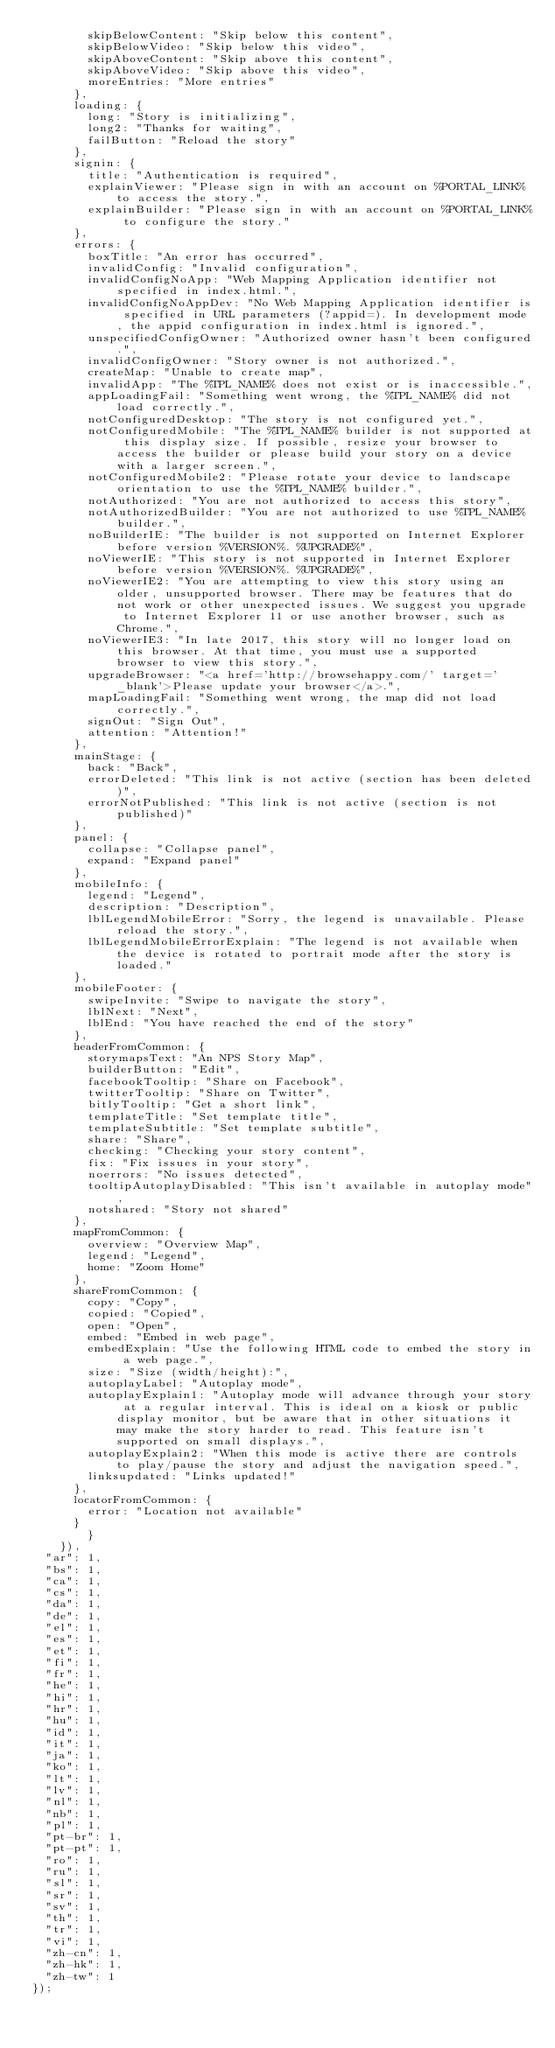Convert code to text. <code><loc_0><loc_0><loc_500><loc_500><_JavaScript_>				skipBelowContent: "Skip below this content",
				skipBelowVideo: "Skip below this video",
				skipAboveContent: "Skip above this content",
				skipAboveVideo: "Skip above this video",
				moreEntries: "More entries"
			},
			loading: {
				long: "Story is initializing",
				long2: "Thanks for waiting",
				failButton: "Reload the story"
			},
			signin: {
				title: "Authentication is required",
				explainViewer: "Please sign in with an account on %PORTAL_LINK% to access the story.",
				explainBuilder: "Please sign in with an account on %PORTAL_LINK% to configure the story."
			},
			errors: {
				boxTitle: "An error has occurred",
				invalidConfig: "Invalid configuration",
				invalidConfigNoApp: "Web Mapping Application identifier not specified in index.html.",
				invalidConfigNoAppDev: "No Web Mapping Application identifier is specified in URL parameters (?appid=). In development mode, the appid configuration in index.html is ignored.",
				unspecifiedConfigOwner: "Authorized owner hasn't been configured.",
				invalidConfigOwner: "Story owner is not authorized.",
				createMap: "Unable to create map",
				invalidApp: "The %TPL_NAME% does not exist or is inaccessible.",
				appLoadingFail: "Something went wrong, the %TPL_NAME% did not load correctly.",
				notConfiguredDesktop: "The story is not configured yet.",
				notConfiguredMobile: "The %TPL_NAME% builder is not supported at this display size. If possible, resize your browser to access the builder or please build your story on a device with a larger screen.",
				notConfiguredMobile2: "Please rotate your device to landscape orientation to use the %TPL_NAME% builder.",
				notAuthorized: "You are not authorized to access this story",
				notAuthorizedBuilder: "You are not authorized to use %TPL_NAME% builder.",
				noBuilderIE: "The builder is not supported on Internet Explorer before version %VERSION%. %UPGRADE%",
				noViewerIE: "This story is not supported in Internet Explorer before version %VERSION%. %UPGRADE%",
				noViewerIE2: "You are attempting to view this story using an older, unsupported browser. There may be features that do not work or other unexpected issues. We suggest you upgrade to Internet Explorer 11 or use another browser, such as Chrome.",
				noViewerIE3: "In late 2017, this story will no longer load on this browser. At that time, you must use a supported browser to view this story.",
				upgradeBrowser: "<a href='http://browsehappy.com/' target='_blank'>Please update your browser</a>.",
				mapLoadingFail: "Something went wrong, the map did not load correctly.",
				signOut: "Sign Out",
				attention: "Attention!"
			},
			mainStage: {
				back: "Back",
				errorDeleted: "This link is not active (section has been deleted)",
				errorNotPublished: "This link is not active (section is not published)"
			},
			panel: {
				collapse: "Collapse panel",
				expand: "Expand panel"
			},
			mobileInfo: {
				legend: "Legend",
				description: "Description",
				lblLegendMobileError: "Sorry, the legend is unavailable. Please reload the story.",
				lblLegendMobileErrorExplain: "The legend is not available when the device is rotated to portrait mode after the story is loaded."
			},
			mobileFooter: {
				swipeInvite: "Swipe to navigate the story",
				lblNext: "Next",
				lblEnd: "You have reached the end of the story"
			},
			headerFromCommon: {
				storymapsText: "An NPS Story Map",
				builderButton: "Edit",
				facebookTooltip: "Share on Facebook",
				twitterTooltip: "Share on Twitter",
				bitlyTooltip: "Get a short link",
				templateTitle: "Set template title",
				templateSubtitle: "Set template subtitle",
				share: "Share",
				checking: "Checking your story content",
				fix: "Fix issues in your story",
				noerrors: "No issues detected",
				tooltipAutoplayDisabled: "This isn't available in autoplay mode",
				notshared: "Story not shared"
			},
			mapFromCommon: {
				overview: "Overview Map",
				legend: "Legend",
				home: "Zoom Home"
			},
			shareFromCommon: {
				copy: "Copy",
				copied: "Copied",
				open: "Open",
				embed: "Embed in web page",
				embedExplain: "Use the following HTML code to embed the story in a web page.",
				size: "Size (width/height):",
				autoplayLabel: "Autoplay mode",
				autoplayExplain1: "Autoplay mode will advance through your story at a regular interval. This is ideal on a kiosk or public display monitor, but be aware that in other situations it may make the story harder to read. This feature isn't supported on small displays.",
				autoplayExplain2: "When this mode is active there are controls to play/pause the story and adjust the navigation speed.",
				linksupdated: "Links updated!"
			},
			locatorFromCommon: {
				error: "Location not available"
			}
        }
    }),
	"ar": 1,
	"bs": 1,
	"ca": 1,
	"cs": 1,
	"da": 1,
	"de": 1,
	"el": 1,
	"es": 1,
	"et": 1,
	"fi": 1,
	"fr": 1,
	"he": 1,
	"hi": 1,
	"hr": 1,
	"hu": 1,
	"id": 1,
	"it": 1,
	"ja": 1,
	"ko": 1,
	"lt": 1,
	"lv": 1,
	"nl": 1,
	"nb": 1,
	"pl": 1,
	"pt-br": 1,
	"pt-pt": 1,
	"ro": 1,
	"ru": 1,
	"sl": 1,
	"sr": 1,
	"sv": 1,
	"th": 1,
	"tr": 1,
	"vi": 1,
	"zh-cn": 1,
	"zh-hk": 1,
	"zh-tw": 1
});
</code> 